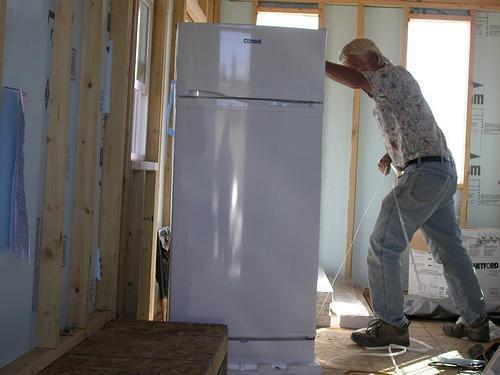How many people in the shot?
Give a very brief answer. 1. How many people are there?
Give a very brief answer. 1. 